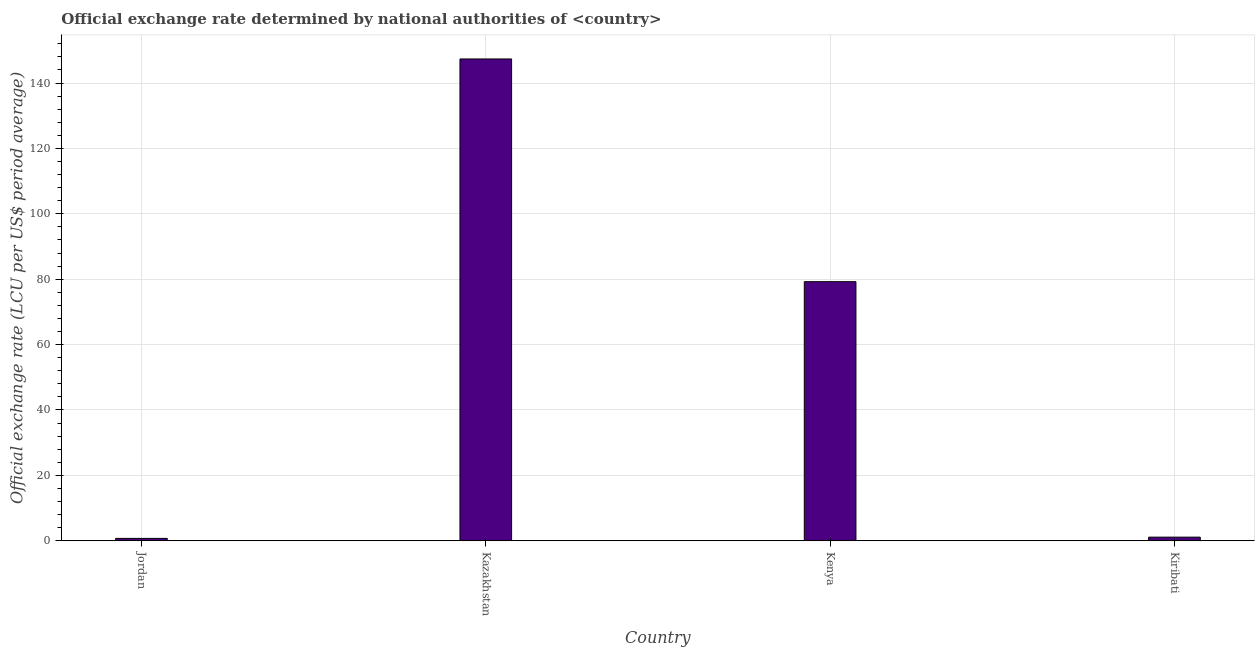Does the graph contain grids?
Your answer should be very brief. Yes. What is the title of the graph?
Ensure brevity in your answer.  Official exchange rate determined by national authorities of <country>. What is the label or title of the X-axis?
Offer a terse response. Country. What is the label or title of the Y-axis?
Your answer should be very brief. Official exchange rate (LCU per US$ period average). What is the official exchange rate in Kiribati?
Give a very brief answer. 1.09. Across all countries, what is the maximum official exchange rate?
Offer a terse response. 147.35. Across all countries, what is the minimum official exchange rate?
Make the answer very short. 0.71. In which country was the official exchange rate maximum?
Make the answer very short. Kazakhstan. In which country was the official exchange rate minimum?
Your answer should be very brief. Jordan. What is the sum of the official exchange rate?
Offer a terse response. 228.39. What is the difference between the official exchange rate in Jordan and Kenya?
Offer a terse response. -78.52. What is the average official exchange rate per country?
Ensure brevity in your answer.  57.1. What is the median official exchange rate?
Offer a terse response. 40.16. What is the ratio of the official exchange rate in Kazakhstan to that in Kenya?
Keep it short and to the point. 1.86. Is the difference between the official exchange rate in Jordan and Kazakhstan greater than the difference between any two countries?
Your response must be concise. Yes. What is the difference between the highest and the second highest official exchange rate?
Provide a short and direct response. 68.12. What is the difference between the highest and the lowest official exchange rate?
Your response must be concise. 146.64. In how many countries, is the official exchange rate greater than the average official exchange rate taken over all countries?
Make the answer very short. 2. How many bars are there?
Give a very brief answer. 4. Are all the bars in the graph horizontal?
Give a very brief answer. No. What is the difference between two consecutive major ticks on the Y-axis?
Offer a very short reply. 20. What is the Official exchange rate (LCU per US$ period average) of Jordan?
Make the answer very short. 0.71. What is the Official exchange rate (LCU per US$ period average) in Kazakhstan?
Offer a very short reply. 147.35. What is the Official exchange rate (LCU per US$ period average) of Kenya?
Provide a short and direct response. 79.23. What is the Official exchange rate (LCU per US$ period average) in Kiribati?
Keep it short and to the point. 1.09. What is the difference between the Official exchange rate (LCU per US$ period average) in Jordan and Kazakhstan?
Provide a short and direct response. -146.65. What is the difference between the Official exchange rate (LCU per US$ period average) in Jordan and Kenya?
Keep it short and to the point. -78.52. What is the difference between the Official exchange rate (LCU per US$ period average) in Jordan and Kiribati?
Offer a terse response. -0.38. What is the difference between the Official exchange rate (LCU per US$ period average) in Kazakhstan and Kenya?
Offer a terse response. 68.12. What is the difference between the Official exchange rate (LCU per US$ period average) in Kazakhstan and Kiribati?
Offer a terse response. 146.26. What is the difference between the Official exchange rate (LCU per US$ period average) in Kenya and Kiribati?
Keep it short and to the point. 78.14. What is the ratio of the Official exchange rate (LCU per US$ period average) in Jordan to that in Kazakhstan?
Provide a succinct answer. 0.01. What is the ratio of the Official exchange rate (LCU per US$ period average) in Jordan to that in Kenya?
Offer a very short reply. 0.01. What is the ratio of the Official exchange rate (LCU per US$ period average) in Jordan to that in Kiribati?
Offer a terse response. 0.65. What is the ratio of the Official exchange rate (LCU per US$ period average) in Kazakhstan to that in Kenya?
Ensure brevity in your answer.  1.86. What is the ratio of the Official exchange rate (LCU per US$ period average) in Kazakhstan to that in Kiribati?
Ensure brevity in your answer.  135.17. What is the ratio of the Official exchange rate (LCU per US$ period average) in Kenya to that in Kiribati?
Ensure brevity in your answer.  72.68. 